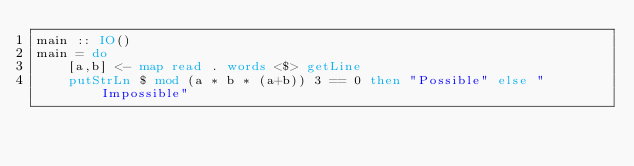Convert code to text. <code><loc_0><loc_0><loc_500><loc_500><_Haskell_>main :: IO()
main = do
    [a,b] <- map read . words <$> getLine
    putStrLn $ mod (a * b * (a+b)) 3 == 0 then "Possible" else "Impossible"</code> 